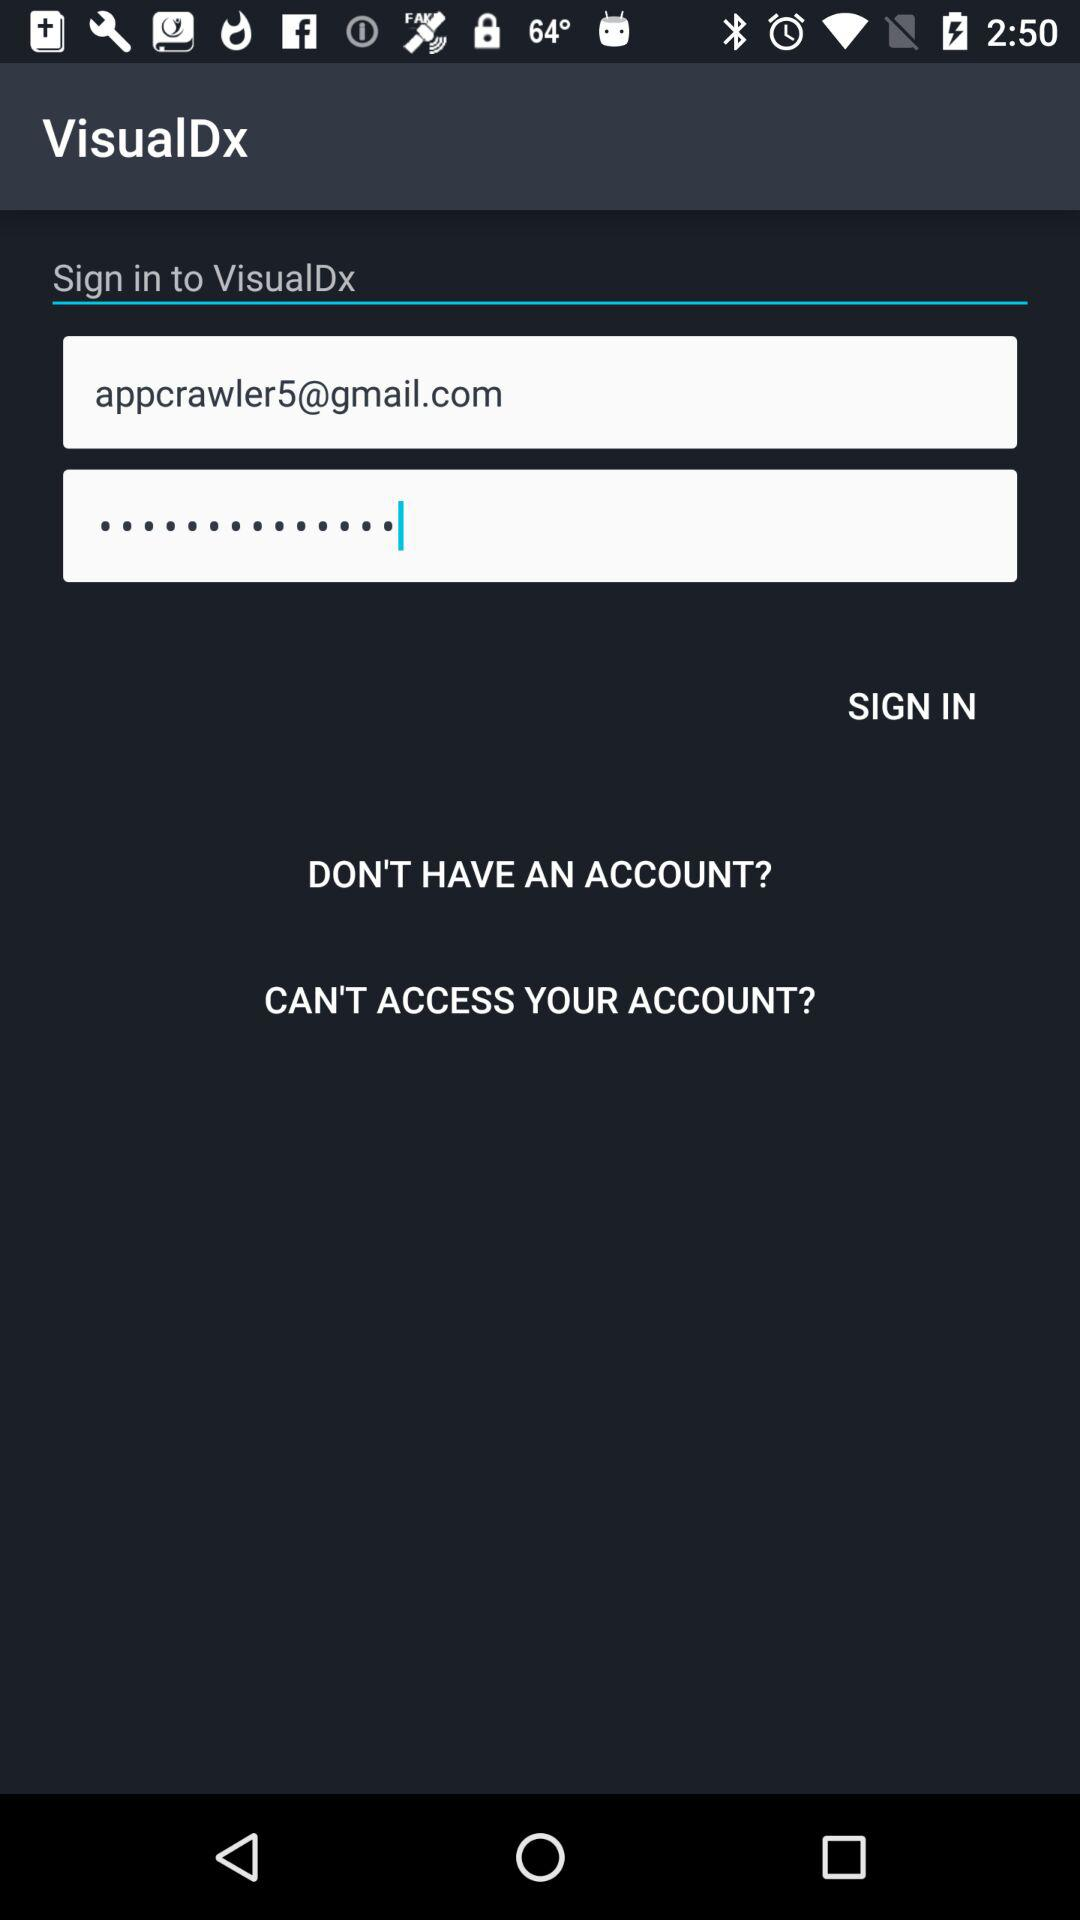What is the name of the application? The name of the application is "VisualDx". 